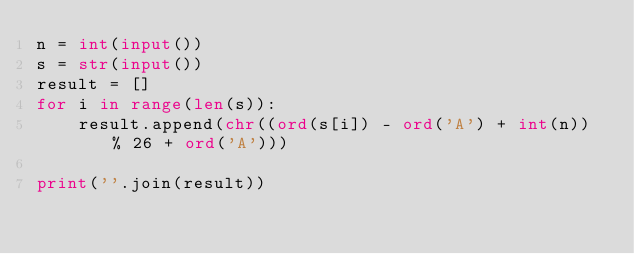Convert code to text. <code><loc_0><loc_0><loc_500><loc_500><_Python_>n = int(input())
s = str(input())
result = []
for i in range(len(s)):
    result.append(chr((ord(s[i]) - ord('A') + int(n)) % 26 + ord('A')))

print(''.join(result))</code> 